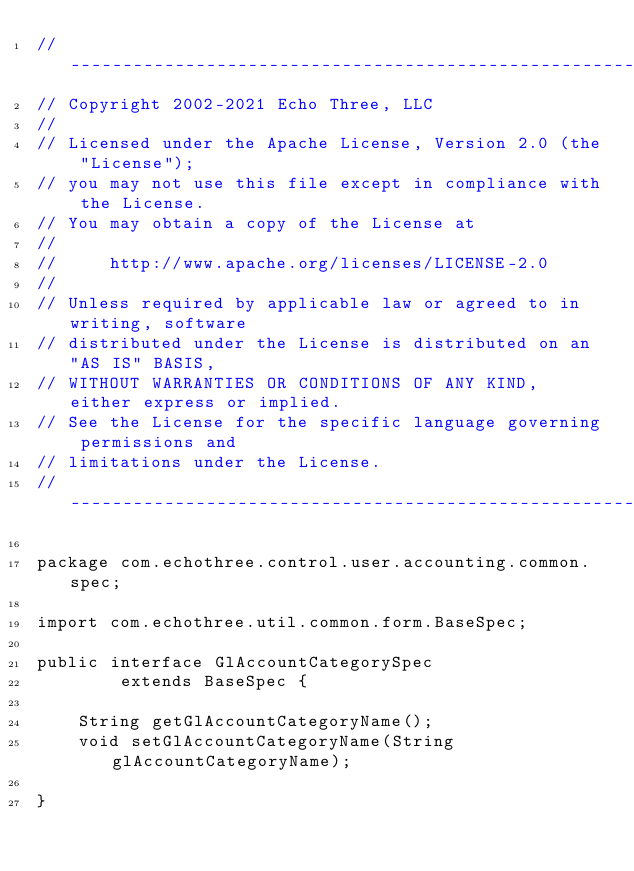<code> <loc_0><loc_0><loc_500><loc_500><_Java_>// --------------------------------------------------------------------------------
// Copyright 2002-2021 Echo Three, LLC
//
// Licensed under the Apache License, Version 2.0 (the "License");
// you may not use this file except in compliance with the License.
// You may obtain a copy of the License at
//
//     http://www.apache.org/licenses/LICENSE-2.0
//
// Unless required by applicable law or agreed to in writing, software
// distributed under the License is distributed on an "AS IS" BASIS,
// WITHOUT WARRANTIES OR CONDITIONS OF ANY KIND, either express or implied.
// See the License for the specific language governing permissions and
// limitations under the License.
// --------------------------------------------------------------------------------

package com.echothree.control.user.accounting.common.spec;

import com.echothree.util.common.form.BaseSpec;

public interface GlAccountCategorySpec
        extends BaseSpec {
    
    String getGlAccountCategoryName();
    void setGlAccountCategoryName(String glAccountCategoryName);
    
}
</code> 